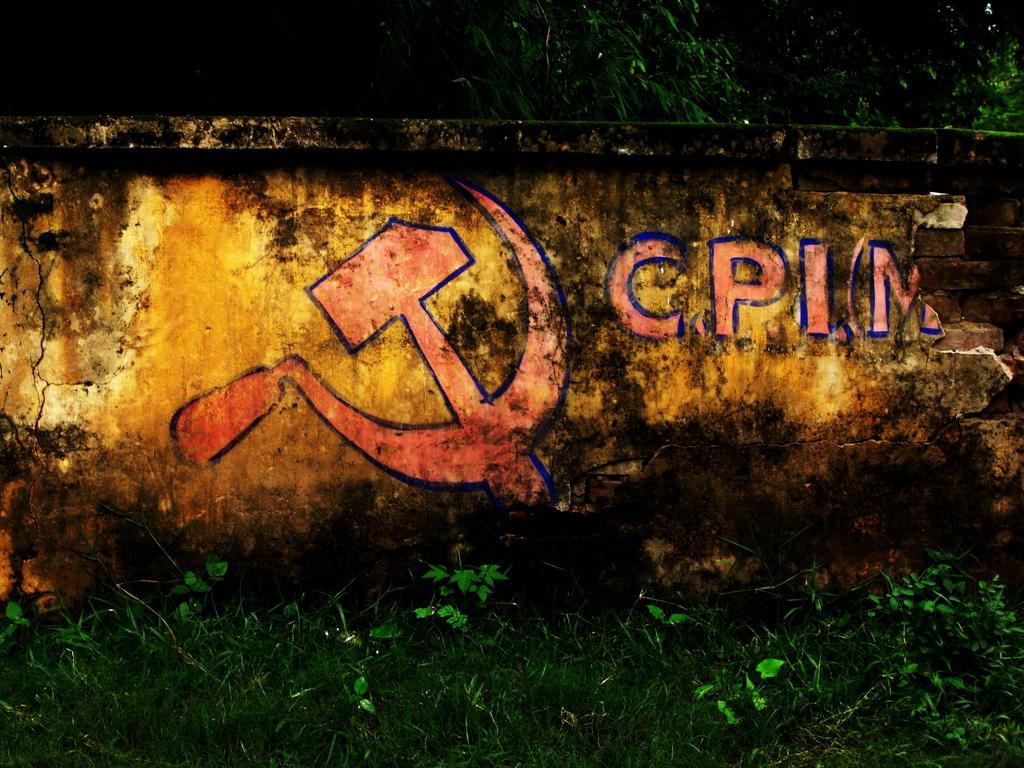Could you give a brief overview of what you see in this image? In this picture I can see painting on the wall, there are plants, grass, and in the background there are trees. 